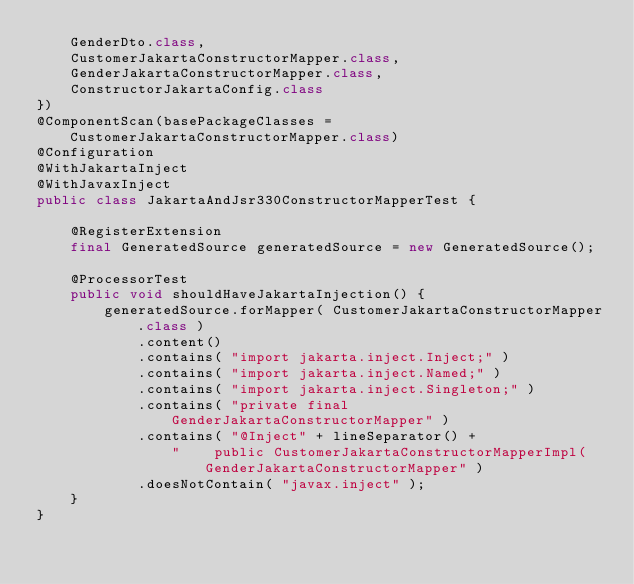<code> <loc_0><loc_0><loc_500><loc_500><_Java_>    GenderDto.class,
    CustomerJakartaConstructorMapper.class,
    GenderJakartaConstructorMapper.class,
    ConstructorJakartaConfig.class
})
@ComponentScan(basePackageClasses = CustomerJakartaConstructorMapper.class)
@Configuration
@WithJakartaInject
@WithJavaxInject
public class JakartaAndJsr330ConstructorMapperTest {

    @RegisterExtension
    final GeneratedSource generatedSource = new GeneratedSource();

    @ProcessorTest
    public void shouldHaveJakartaInjection() {
        generatedSource.forMapper( CustomerJakartaConstructorMapper.class )
            .content()
            .contains( "import jakarta.inject.Inject;" )
            .contains( "import jakarta.inject.Named;" )
            .contains( "import jakarta.inject.Singleton;" )
            .contains( "private final GenderJakartaConstructorMapper" )
            .contains( "@Inject" + lineSeparator() +
                "    public CustomerJakartaConstructorMapperImpl(GenderJakartaConstructorMapper" )
            .doesNotContain( "javax.inject" );
    }
}
</code> 